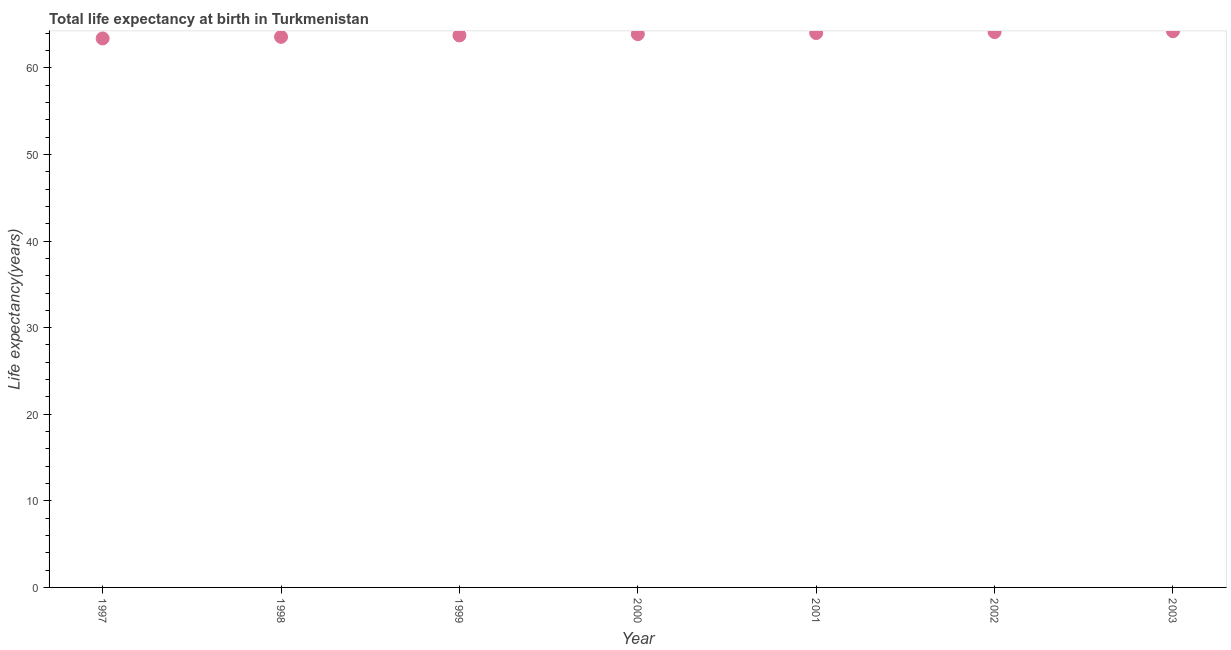What is the life expectancy at birth in 2000?
Provide a short and direct response. 63.9. Across all years, what is the maximum life expectancy at birth?
Give a very brief answer. 64.24. Across all years, what is the minimum life expectancy at birth?
Offer a terse response. 63.4. In which year was the life expectancy at birth maximum?
Your answer should be compact. 2003. In which year was the life expectancy at birth minimum?
Your answer should be very brief. 1997. What is the sum of the life expectancy at birth?
Ensure brevity in your answer.  447.04. What is the difference between the life expectancy at birth in 1999 and 2003?
Your answer should be compact. -0.49. What is the average life expectancy at birth per year?
Your answer should be very brief. 63.86. What is the median life expectancy at birth?
Keep it short and to the point. 63.9. Do a majority of the years between 2001 and 1999 (inclusive) have life expectancy at birth greater than 42 years?
Offer a terse response. No. What is the ratio of the life expectancy at birth in 1999 to that in 2001?
Ensure brevity in your answer.  1. Is the difference between the life expectancy at birth in 1997 and 1998 greater than the difference between any two years?
Your answer should be very brief. No. What is the difference between the highest and the second highest life expectancy at birth?
Your answer should be compact. 0.1. What is the difference between the highest and the lowest life expectancy at birth?
Your answer should be very brief. 0.84. How many dotlines are there?
Your answer should be compact. 1. Does the graph contain any zero values?
Ensure brevity in your answer.  No. Does the graph contain grids?
Offer a very short reply. No. What is the title of the graph?
Your answer should be very brief. Total life expectancy at birth in Turkmenistan. What is the label or title of the Y-axis?
Your answer should be compact. Life expectancy(years). What is the Life expectancy(years) in 1997?
Your answer should be compact. 63.4. What is the Life expectancy(years) in 1998?
Provide a succinct answer. 63.58. What is the Life expectancy(years) in 1999?
Make the answer very short. 63.75. What is the Life expectancy(years) in 2000?
Your answer should be very brief. 63.9. What is the Life expectancy(years) in 2001?
Provide a succinct answer. 64.03. What is the Life expectancy(years) in 2002?
Make the answer very short. 64.14. What is the Life expectancy(years) in 2003?
Make the answer very short. 64.24. What is the difference between the Life expectancy(years) in 1997 and 1998?
Offer a very short reply. -0.18. What is the difference between the Life expectancy(years) in 1997 and 1999?
Ensure brevity in your answer.  -0.35. What is the difference between the Life expectancy(years) in 1997 and 2000?
Ensure brevity in your answer.  -0.5. What is the difference between the Life expectancy(years) in 1997 and 2001?
Ensure brevity in your answer.  -0.63. What is the difference between the Life expectancy(years) in 1997 and 2002?
Provide a succinct answer. -0.74. What is the difference between the Life expectancy(years) in 1997 and 2003?
Ensure brevity in your answer.  -0.84. What is the difference between the Life expectancy(years) in 1998 and 1999?
Offer a terse response. -0.17. What is the difference between the Life expectancy(years) in 1998 and 2000?
Your response must be concise. -0.32. What is the difference between the Life expectancy(years) in 1998 and 2001?
Provide a succinct answer. -0.44. What is the difference between the Life expectancy(years) in 1998 and 2002?
Keep it short and to the point. -0.56. What is the difference between the Life expectancy(years) in 1998 and 2003?
Offer a very short reply. -0.66. What is the difference between the Life expectancy(years) in 1999 and 2000?
Provide a short and direct response. -0.15. What is the difference between the Life expectancy(years) in 1999 and 2001?
Provide a succinct answer. -0.27. What is the difference between the Life expectancy(years) in 1999 and 2002?
Offer a very short reply. -0.39. What is the difference between the Life expectancy(years) in 1999 and 2003?
Your answer should be very brief. -0.49. What is the difference between the Life expectancy(years) in 2000 and 2001?
Give a very brief answer. -0.13. What is the difference between the Life expectancy(years) in 2000 and 2002?
Keep it short and to the point. -0.24. What is the difference between the Life expectancy(years) in 2000 and 2003?
Make the answer very short. -0.34. What is the difference between the Life expectancy(years) in 2001 and 2002?
Your response must be concise. -0.11. What is the difference between the Life expectancy(years) in 2001 and 2003?
Your answer should be compact. -0.21. What is the difference between the Life expectancy(years) in 2002 and 2003?
Your answer should be compact. -0.1. What is the ratio of the Life expectancy(years) in 1997 to that in 1999?
Provide a short and direct response. 0.99. What is the ratio of the Life expectancy(years) in 1997 to that in 2000?
Your response must be concise. 0.99. What is the ratio of the Life expectancy(years) in 1997 to that in 2001?
Your answer should be compact. 0.99. What is the ratio of the Life expectancy(years) in 1997 to that in 2002?
Ensure brevity in your answer.  0.99. What is the ratio of the Life expectancy(years) in 1998 to that in 1999?
Provide a short and direct response. 1. What is the ratio of the Life expectancy(years) in 1998 to that in 2000?
Offer a terse response. 0.99. What is the ratio of the Life expectancy(years) in 1998 to that in 2003?
Give a very brief answer. 0.99. What is the ratio of the Life expectancy(years) in 1999 to that in 2001?
Make the answer very short. 1. What is the ratio of the Life expectancy(years) in 2001 to that in 2003?
Your answer should be very brief. 1. 